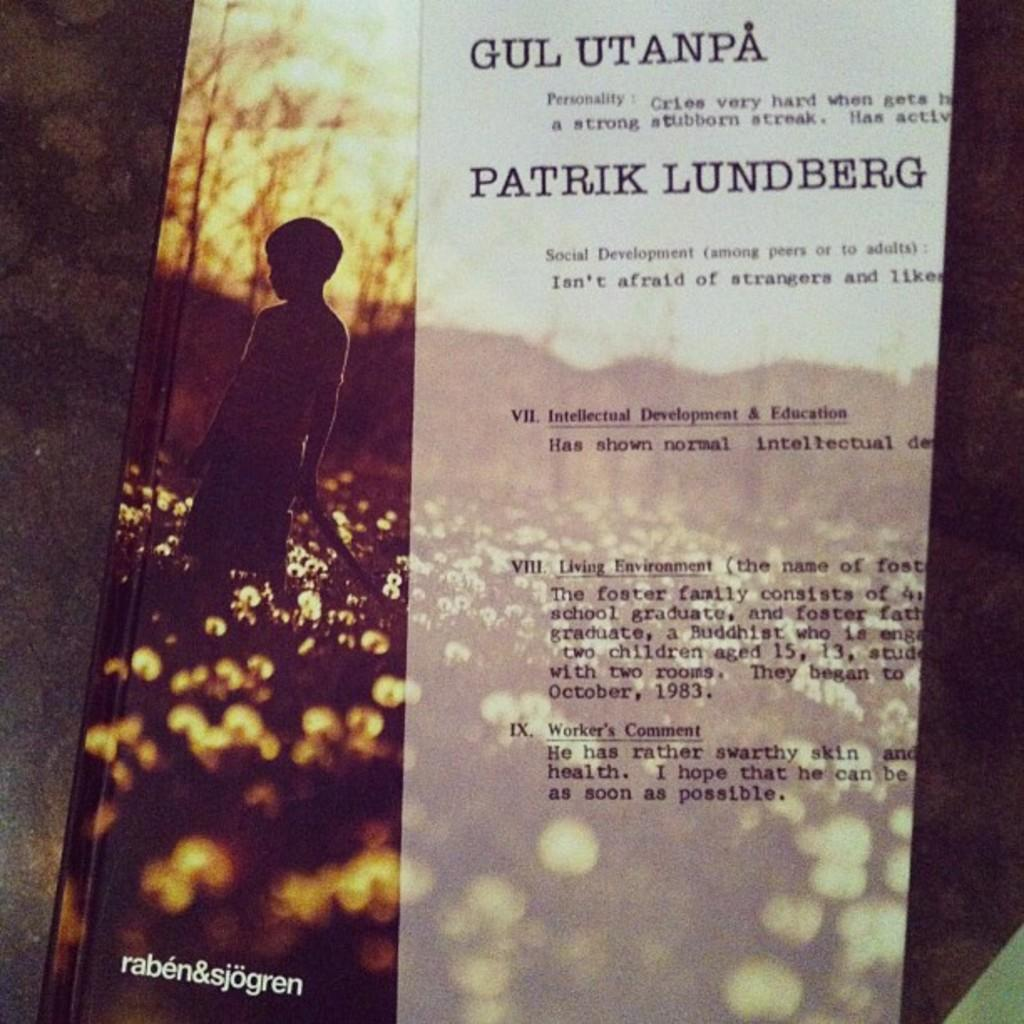What object can be seen in the image that contains text? There is a book in the image that has text on it. Who is present in the image? There is a boy in the image. What type of natural elements can be seen in the image? There are trees, plants, and flowers in the image. Can you describe the setting of the image? The image features a boy and various natural elements, which might suggest a background with a table. What is the income of the orange tree in the image? There is no orange tree present in the image, so it is not possible to determine its income. 